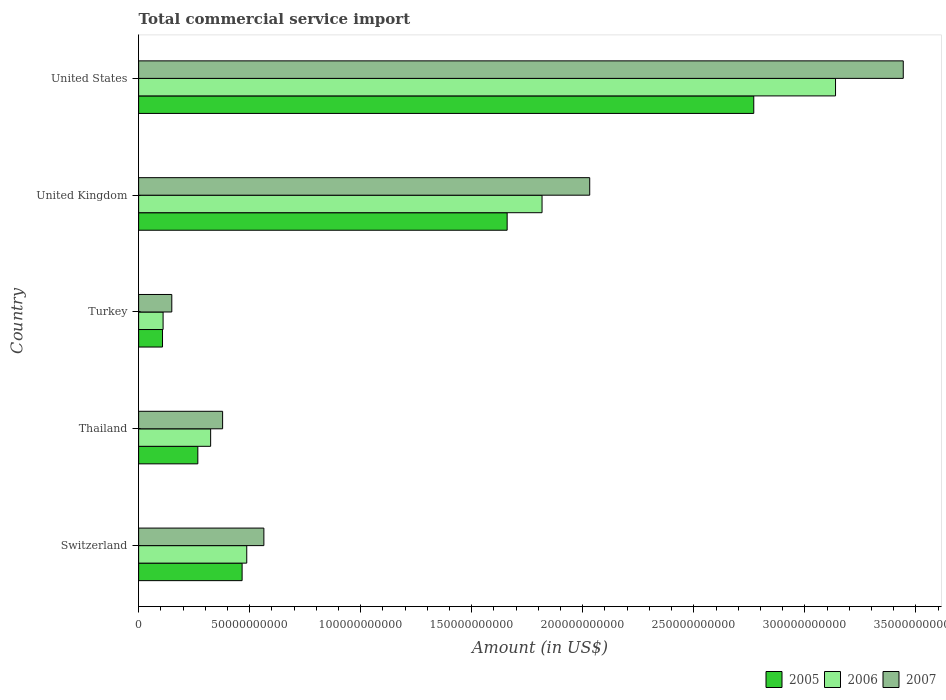Are the number of bars per tick equal to the number of legend labels?
Give a very brief answer. Yes. Are the number of bars on each tick of the Y-axis equal?
Your answer should be very brief. Yes. How many bars are there on the 3rd tick from the top?
Make the answer very short. 3. How many bars are there on the 4th tick from the bottom?
Ensure brevity in your answer.  3. What is the total commercial service import in 2007 in United Kingdom?
Provide a short and direct response. 2.03e+11. Across all countries, what is the maximum total commercial service import in 2007?
Ensure brevity in your answer.  3.44e+11. Across all countries, what is the minimum total commercial service import in 2007?
Offer a very short reply. 1.49e+1. In which country was the total commercial service import in 2007 maximum?
Provide a short and direct response. United States. In which country was the total commercial service import in 2005 minimum?
Keep it short and to the point. Turkey. What is the total total commercial service import in 2006 in the graph?
Your response must be concise. 5.88e+11. What is the difference between the total commercial service import in 2007 in United Kingdom and that in United States?
Make the answer very short. -1.41e+11. What is the difference between the total commercial service import in 2007 in United States and the total commercial service import in 2006 in Switzerland?
Your answer should be very brief. 2.96e+11. What is the average total commercial service import in 2005 per country?
Offer a terse response. 1.05e+11. What is the difference between the total commercial service import in 2007 and total commercial service import in 2006 in Turkey?
Ensure brevity in your answer.  3.92e+09. In how many countries, is the total commercial service import in 2005 greater than 40000000000 US$?
Keep it short and to the point. 3. What is the ratio of the total commercial service import in 2007 in Thailand to that in Turkey?
Keep it short and to the point. 2.53. What is the difference between the highest and the second highest total commercial service import in 2007?
Provide a short and direct response. 1.41e+11. What is the difference between the highest and the lowest total commercial service import in 2007?
Keep it short and to the point. 3.29e+11. How many bars are there?
Make the answer very short. 15. Does the graph contain any zero values?
Provide a short and direct response. No. Where does the legend appear in the graph?
Provide a short and direct response. Bottom right. How are the legend labels stacked?
Provide a short and direct response. Horizontal. What is the title of the graph?
Your answer should be compact. Total commercial service import. Does "1963" appear as one of the legend labels in the graph?
Offer a terse response. No. What is the label or title of the Y-axis?
Ensure brevity in your answer.  Country. What is the Amount (in US$) of 2005 in Switzerland?
Your response must be concise. 4.66e+1. What is the Amount (in US$) of 2006 in Switzerland?
Offer a terse response. 4.87e+1. What is the Amount (in US$) of 2007 in Switzerland?
Your answer should be very brief. 5.64e+1. What is the Amount (in US$) in 2005 in Thailand?
Your answer should be compact. 2.67e+1. What is the Amount (in US$) in 2006 in Thailand?
Your answer should be compact. 3.24e+1. What is the Amount (in US$) of 2007 in Thailand?
Provide a succinct answer. 3.78e+1. What is the Amount (in US$) of 2005 in Turkey?
Offer a very short reply. 1.08e+1. What is the Amount (in US$) in 2006 in Turkey?
Make the answer very short. 1.10e+1. What is the Amount (in US$) in 2007 in Turkey?
Give a very brief answer. 1.49e+1. What is the Amount (in US$) of 2005 in United Kingdom?
Keep it short and to the point. 1.66e+11. What is the Amount (in US$) of 2006 in United Kingdom?
Offer a terse response. 1.82e+11. What is the Amount (in US$) in 2007 in United Kingdom?
Offer a terse response. 2.03e+11. What is the Amount (in US$) in 2005 in United States?
Your answer should be very brief. 2.77e+11. What is the Amount (in US$) in 2006 in United States?
Your answer should be compact. 3.14e+11. What is the Amount (in US$) of 2007 in United States?
Provide a short and direct response. 3.44e+11. Across all countries, what is the maximum Amount (in US$) in 2005?
Your response must be concise. 2.77e+11. Across all countries, what is the maximum Amount (in US$) in 2006?
Provide a short and direct response. 3.14e+11. Across all countries, what is the maximum Amount (in US$) of 2007?
Your response must be concise. 3.44e+11. Across all countries, what is the minimum Amount (in US$) of 2005?
Provide a short and direct response. 1.08e+1. Across all countries, what is the minimum Amount (in US$) in 2006?
Give a very brief answer. 1.10e+1. Across all countries, what is the minimum Amount (in US$) of 2007?
Offer a terse response. 1.49e+1. What is the total Amount (in US$) in 2005 in the graph?
Offer a very short reply. 5.27e+11. What is the total Amount (in US$) in 2006 in the graph?
Your response must be concise. 5.88e+11. What is the total Amount (in US$) in 2007 in the graph?
Your response must be concise. 6.57e+11. What is the difference between the Amount (in US$) of 2005 in Switzerland and that in Thailand?
Your answer should be compact. 1.99e+1. What is the difference between the Amount (in US$) of 2006 in Switzerland and that in Thailand?
Ensure brevity in your answer.  1.63e+1. What is the difference between the Amount (in US$) in 2007 in Switzerland and that in Thailand?
Your answer should be compact. 1.86e+1. What is the difference between the Amount (in US$) in 2005 in Switzerland and that in Turkey?
Offer a very short reply. 3.58e+1. What is the difference between the Amount (in US$) in 2006 in Switzerland and that in Turkey?
Make the answer very short. 3.77e+1. What is the difference between the Amount (in US$) of 2007 in Switzerland and that in Turkey?
Provide a short and direct response. 4.15e+1. What is the difference between the Amount (in US$) of 2005 in Switzerland and that in United Kingdom?
Make the answer very short. -1.19e+11. What is the difference between the Amount (in US$) in 2006 in Switzerland and that in United Kingdom?
Offer a terse response. -1.33e+11. What is the difference between the Amount (in US$) of 2007 in Switzerland and that in United Kingdom?
Offer a terse response. -1.47e+11. What is the difference between the Amount (in US$) in 2005 in Switzerland and that in United States?
Provide a succinct answer. -2.30e+11. What is the difference between the Amount (in US$) of 2006 in Switzerland and that in United States?
Offer a very short reply. -2.65e+11. What is the difference between the Amount (in US$) of 2007 in Switzerland and that in United States?
Make the answer very short. -2.88e+11. What is the difference between the Amount (in US$) in 2005 in Thailand and that in Turkey?
Provide a short and direct response. 1.59e+1. What is the difference between the Amount (in US$) of 2006 in Thailand and that in Turkey?
Ensure brevity in your answer.  2.14e+1. What is the difference between the Amount (in US$) of 2007 in Thailand and that in Turkey?
Keep it short and to the point. 2.29e+1. What is the difference between the Amount (in US$) of 2005 in Thailand and that in United Kingdom?
Your answer should be very brief. -1.39e+11. What is the difference between the Amount (in US$) of 2006 in Thailand and that in United Kingdom?
Ensure brevity in your answer.  -1.49e+11. What is the difference between the Amount (in US$) in 2007 in Thailand and that in United Kingdom?
Give a very brief answer. -1.65e+11. What is the difference between the Amount (in US$) in 2005 in Thailand and that in United States?
Provide a succinct answer. -2.50e+11. What is the difference between the Amount (in US$) of 2006 in Thailand and that in United States?
Give a very brief answer. -2.81e+11. What is the difference between the Amount (in US$) in 2007 in Thailand and that in United States?
Your response must be concise. -3.06e+11. What is the difference between the Amount (in US$) of 2005 in Turkey and that in United Kingdom?
Make the answer very short. -1.55e+11. What is the difference between the Amount (in US$) in 2006 in Turkey and that in United Kingdom?
Your answer should be compact. -1.71e+11. What is the difference between the Amount (in US$) in 2007 in Turkey and that in United Kingdom?
Your response must be concise. -1.88e+11. What is the difference between the Amount (in US$) in 2005 in Turkey and that in United States?
Make the answer very short. -2.66e+11. What is the difference between the Amount (in US$) of 2006 in Turkey and that in United States?
Keep it short and to the point. -3.03e+11. What is the difference between the Amount (in US$) of 2007 in Turkey and that in United States?
Keep it short and to the point. -3.29e+11. What is the difference between the Amount (in US$) of 2005 in United Kingdom and that in United States?
Ensure brevity in your answer.  -1.11e+11. What is the difference between the Amount (in US$) in 2006 in United Kingdom and that in United States?
Your response must be concise. -1.32e+11. What is the difference between the Amount (in US$) in 2007 in United Kingdom and that in United States?
Your answer should be very brief. -1.41e+11. What is the difference between the Amount (in US$) in 2005 in Switzerland and the Amount (in US$) in 2006 in Thailand?
Ensure brevity in your answer.  1.42e+1. What is the difference between the Amount (in US$) of 2005 in Switzerland and the Amount (in US$) of 2007 in Thailand?
Ensure brevity in your answer.  8.79e+09. What is the difference between the Amount (in US$) of 2006 in Switzerland and the Amount (in US$) of 2007 in Thailand?
Provide a succinct answer. 1.09e+1. What is the difference between the Amount (in US$) of 2005 in Switzerland and the Amount (in US$) of 2006 in Turkey?
Your answer should be very brief. 3.56e+1. What is the difference between the Amount (in US$) in 2005 in Switzerland and the Amount (in US$) in 2007 in Turkey?
Your response must be concise. 3.17e+1. What is the difference between the Amount (in US$) in 2006 in Switzerland and the Amount (in US$) in 2007 in Turkey?
Offer a very short reply. 3.38e+1. What is the difference between the Amount (in US$) of 2005 in Switzerland and the Amount (in US$) of 2006 in United Kingdom?
Your response must be concise. -1.35e+11. What is the difference between the Amount (in US$) in 2005 in Switzerland and the Amount (in US$) in 2007 in United Kingdom?
Make the answer very short. -1.57e+11. What is the difference between the Amount (in US$) in 2006 in Switzerland and the Amount (in US$) in 2007 in United Kingdom?
Keep it short and to the point. -1.54e+11. What is the difference between the Amount (in US$) of 2005 in Switzerland and the Amount (in US$) of 2006 in United States?
Your answer should be compact. -2.67e+11. What is the difference between the Amount (in US$) of 2005 in Switzerland and the Amount (in US$) of 2007 in United States?
Your answer should be very brief. -2.98e+11. What is the difference between the Amount (in US$) in 2006 in Switzerland and the Amount (in US$) in 2007 in United States?
Your answer should be very brief. -2.96e+11. What is the difference between the Amount (in US$) in 2005 in Thailand and the Amount (in US$) in 2006 in Turkey?
Offer a terse response. 1.56e+1. What is the difference between the Amount (in US$) in 2005 in Thailand and the Amount (in US$) in 2007 in Turkey?
Provide a succinct answer. 1.17e+1. What is the difference between the Amount (in US$) of 2006 in Thailand and the Amount (in US$) of 2007 in Turkey?
Provide a short and direct response. 1.75e+1. What is the difference between the Amount (in US$) in 2005 in Thailand and the Amount (in US$) in 2006 in United Kingdom?
Provide a short and direct response. -1.55e+11. What is the difference between the Amount (in US$) of 2005 in Thailand and the Amount (in US$) of 2007 in United Kingdom?
Keep it short and to the point. -1.76e+11. What is the difference between the Amount (in US$) of 2006 in Thailand and the Amount (in US$) of 2007 in United Kingdom?
Offer a very short reply. -1.71e+11. What is the difference between the Amount (in US$) of 2005 in Thailand and the Amount (in US$) of 2006 in United States?
Your response must be concise. -2.87e+11. What is the difference between the Amount (in US$) of 2005 in Thailand and the Amount (in US$) of 2007 in United States?
Your answer should be very brief. -3.18e+11. What is the difference between the Amount (in US$) of 2006 in Thailand and the Amount (in US$) of 2007 in United States?
Ensure brevity in your answer.  -3.12e+11. What is the difference between the Amount (in US$) of 2005 in Turkey and the Amount (in US$) of 2006 in United Kingdom?
Offer a terse response. -1.71e+11. What is the difference between the Amount (in US$) in 2005 in Turkey and the Amount (in US$) in 2007 in United Kingdom?
Make the answer very short. -1.92e+11. What is the difference between the Amount (in US$) of 2006 in Turkey and the Amount (in US$) of 2007 in United Kingdom?
Your response must be concise. -1.92e+11. What is the difference between the Amount (in US$) of 2005 in Turkey and the Amount (in US$) of 2006 in United States?
Provide a short and direct response. -3.03e+11. What is the difference between the Amount (in US$) in 2005 in Turkey and the Amount (in US$) in 2007 in United States?
Provide a short and direct response. -3.34e+11. What is the difference between the Amount (in US$) of 2006 in Turkey and the Amount (in US$) of 2007 in United States?
Offer a terse response. -3.33e+11. What is the difference between the Amount (in US$) of 2005 in United Kingdom and the Amount (in US$) of 2006 in United States?
Make the answer very short. -1.48e+11. What is the difference between the Amount (in US$) of 2005 in United Kingdom and the Amount (in US$) of 2007 in United States?
Offer a terse response. -1.78e+11. What is the difference between the Amount (in US$) of 2006 in United Kingdom and the Amount (in US$) of 2007 in United States?
Provide a succinct answer. -1.63e+11. What is the average Amount (in US$) of 2005 per country?
Keep it short and to the point. 1.05e+11. What is the average Amount (in US$) of 2006 per country?
Provide a succinct answer. 1.18e+11. What is the average Amount (in US$) in 2007 per country?
Offer a terse response. 1.31e+11. What is the difference between the Amount (in US$) in 2005 and Amount (in US$) in 2006 in Switzerland?
Give a very brief answer. -2.09e+09. What is the difference between the Amount (in US$) of 2005 and Amount (in US$) of 2007 in Switzerland?
Your answer should be compact. -9.80e+09. What is the difference between the Amount (in US$) of 2006 and Amount (in US$) of 2007 in Switzerland?
Provide a short and direct response. -7.71e+09. What is the difference between the Amount (in US$) of 2005 and Amount (in US$) of 2006 in Thailand?
Provide a short and direct response. -5.77e+09. What is the difference between the Amount (in US$) in 2005 and Amount (in US$) in 2007 in Thailand?
Offer a very short reply. -1.12e+1. What is the difference between the Amount (in US$) of 2006 and Amount (in US$) of 2007 in Thailand?
Provide a short and direct response. -5.38e+09. What is the difference between the Amount (in US$) in 2005 and Amount (in US$) in 2006 in Turkey?
Ensure brevity in your answer.  -2.61e+08. What is the difference between the Amount (in US$) in 2005 and Amount (in US$) in 2007 in Turkey?
Offer a very short reply. -4.18e+09. What is the difference between the Amount (in US$) in 2006 and Amount (in US$) in 2007 in Turkey?
Your response must be concise. -3.92e+09. What is the difference between the Amount (in US$) of 2005 and Amount (in US$) of 2006 in United Kingdom?
Provide a succinct answer. -1.57e+1. What is the difference between the Amount (in US$) in 2005 and Amount (in US$) in 2007 in United Kingdom?
Your answer should be very brief. -3.72e+1. What is the difference between the Amount (in US$) in 2006 and Amount (in US$) in 2007 in United Kingdom?
Keep it short and to the point. -2.15e+1. What is the difference between the Amount (in US$) of 2005 and Amount (in US$) of 2006 in United States?
Provide a short and direct response. -3.68e+1. What is the difference between the Amount (in US$) in 2005 and Amount (in US$) in 2007 in United States?
Give a very brief answer. -6.73e+1. What is the difference between the Amount (in US$) of 2006 and Amount (in US$) of 2007 in United States?
Provide a short and direct response. -3.05e+1. What is the ratio of the Amount (in US$) in 2005 in Switzerland to that in Thailand?
Your response must be concise. 1.75. What is the ratio of the Amount (in US$) in 2006 in Switzerland to that in Thailand?
Offer a terse response. 1.5. What is the ratio of the Amount (in US$) in 2007 in Switzerland to that in Thailand?
Offer a very short reply. 1.49. What is the ratio of the Amount (in US$) of 2005 in Switzerland to that in Turkey?
Offer a terse response. 4.33. What is the ratio of the Amount (in US$) of 2006 in Switzerland to that in Turkey?
Offer a very short reply. 4.42. What is the ratio of the Amount (in US$) in 2007 in Switzerland to that in Turkey?
Provide a short and direct response. 3.78. What is the ratio of the Amount (in US$) of 2005 in Switzerland to that in United Kingdom?
Offer a terse response. 0.28. What is the ratio of the Amount (in US$) of 2006 in Switzerland to that in United Kingdom?
Offer a terse response. 0.27. What is the ratio of the Amount (in US$) of 2007 in Switzerland to that in United Kingdom?
Make the answer very short. 0.28. What is the ratio of the Amount (in US$) in 2005 in Switzerland to that in United States?
Your response must be concise. 0.17. What is the ratio of the Amount (in US$) of 2006 in Switzerland to that in United States?
Make the answer very short. 0.16. What is the ratio of the Amount (in US$) in 2007 in Switzerland to that in United States?
Offer a terse response. 0.16. What is the ratio of the Amount (in US$) in 2005 in Thailand to that in Turkey?
Make the answer very short. 2.48. What is the ratio of the Amount (in US$) in 2006 in Thailand to that in Turkey?
Your response must be concise. 2.94. What is the ratio of the Amount (in US$) of 2007 in Thailand to that in Turkey?
Your response must be concise. 2.53. What is the ratio of the Amount (in US$) of 2005 in Thailand to that in United Kingdom?
Give a very brief answer. 0.16. What is the ratio of the Amount (in US$) of 2006 in Thailand to that in United Kingdom?
Provide a short and direct response. 0.18. What is the ratio of the Amount (in US$) in 2007 in Thailand to that in United Kingdom?
Keep it short and to the point. 0.19. What is the ratio of the Amount (in US$) of 2005 in Thailand to that in United States?
Your answer should be very brief. 0.1. What is the ratio of the Amount (in US$) of 2006 in Thailand to that in United States?
Give a very brief answer. 0.1. What is the ratio of the Amount (in US$) in 2007 in Thailand to that in United States?
Your response must be concise. 0.11. What is the ratio of the Amount (in US$) in 2005 in Turkey to that in United Kingdom?
Make the answer very short. 0.06. What is the ratio of the Amount (in US$) of 2006 in Turkey to that in United Kingdom?
Your answer should be compact. 0.06. What is the ratio of the Amount (in US$) in 2007 in Turkey to that in United Kingdom?
Offer a terse response. 0.07. What is the ratio of the Amount (in US$) of 2005 in Turkey to that in United States?
Provide a succinct answer. 0.04. What is the ratio of the Amount (in US$) of 2006 in Turkey to that in United States?
Provide a short and direct response. 0.04. What is the ratio of the Amount (in US$) of 2007 in Turkey to that in United States?
Make the answer very short. 0.04. What is the ratio of the Amount (in US$) in 2005 in United Kingdom to that in United States?
Your response must be concise. 0.6. What is the ratio of the Amount (in US$) in 2006 in United Kingdom to that in United States?
Offer a very short reply. 0.58. What is the ratio of the Amount (in US$) of 2007 in United Kingdom to that in United States?
Ensure brevity in your answer.  0.59. What is the difference between the highest and the second highest Amount (in US$) of 2005?
Make the answer very short. 1.11e+11. What is the difference between the highest and the second highest Amount (in US$) of 2006?
Your answer should be very brief. 1.32e+11. What is the difference between the highest and the second highest Amount (in US$) in 2007?
Make the answer very short. 1.41e+11. What is the difference between the highest and the lowest Amount (in US$) in 2005?
Provide a short and direct response. 2.66e+11. What is the difference between the highest and the lowest Amount (in US$) in 2006?
Make the answer very short. 3.03e+11. What is the difference between the highest and the lowest Amount (in US$) in 2007?
Offer a terse response. 3.29e+11. 